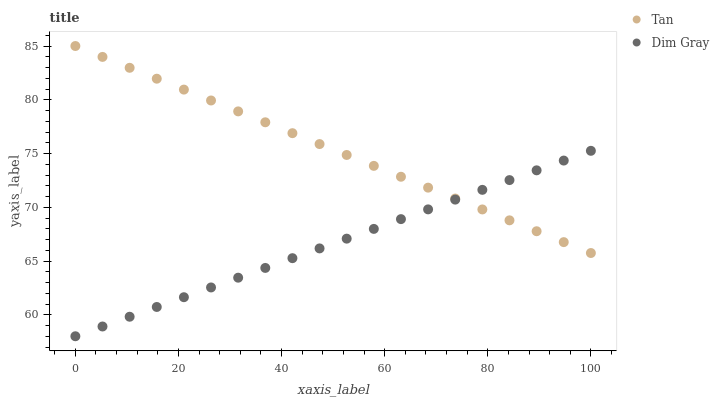Does Dim Gray have the minimum area under the curve?
Answer yes or no. Yes. Does Tan have the maximum area under the curve?
Answer yes or no. Yes. Does Dim Gray have the maximum area under the curve?
Answer yes or no. No. Is Tan the smoothest?
Answer yes or no. Yes. Is Dim Gray the roughest?
Answer yes or no. Yes. Is Dim Gray the smoothest?
Answer yes or no. No. Does Dim Gray have the lowest value?
Answer yes or no. Yes. Does Tan have the highest value?
Answer yes or no. Yes. Does Dim Gray have the highest value?
Answer yes or no. No. Does Dim Gray intersect Tan?
Answer yes or no. Yes. Is Dim Gray less than Tan?
Answer yes or no. No. Is Dim Gray greater than Tan?
Answer yes or no. No. 